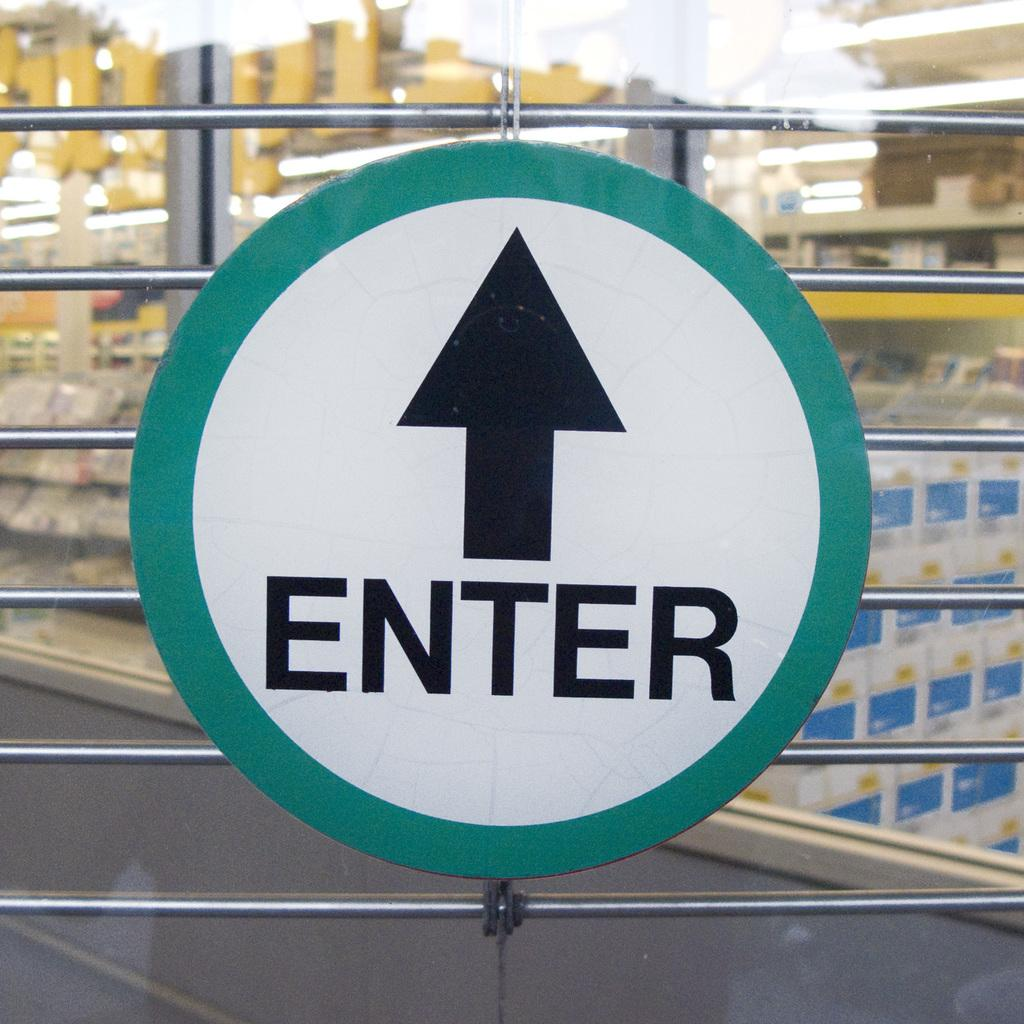<image>
Write a terse but informative summary of the picture. A round sign has an arrow and the word enter. 